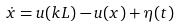Convert formula to latex. <formula><loc_0><loc_0><loc_500><loc_500>\dot { x } = u ( k L ) - u ( x ) + \eta ( t )</formula> 